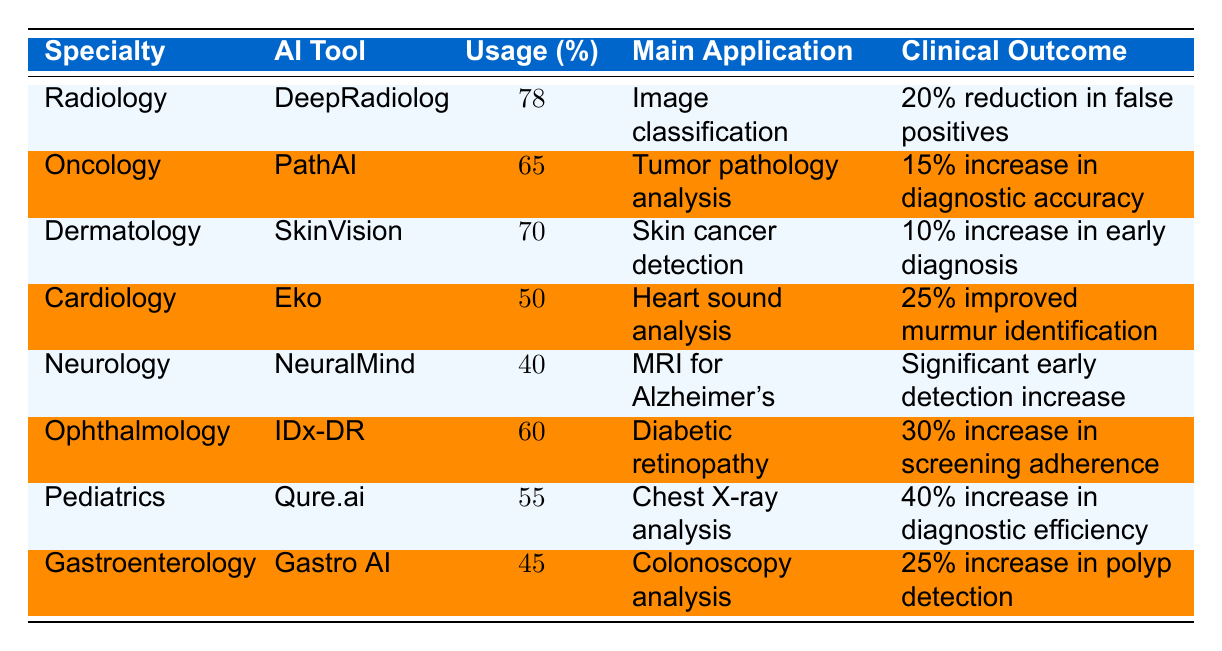What is the AI tool used in Radiology? The table lists the medical specialty of Radiology and the corresponding AI tool, which is DeepRadiology.
Answer: DeepRadiology What is the usage percentage of AI-assisted tools in Oncology? The table shows that the usage percentage of AI-assisted tools in Oncology is 65%.
Answer: 65% Which medical specialty has the highest AI tool utilization? By comparing the usage percentages in the table, Radiology has the highest at 78%.
Answer: Radiology How many medical specialties have an AI tool utilization above 60%? The table shows that Radiology (78%), Oncology (65%), and Dermatology (70%) have usage above 60%, totaling three specialties.
Answer: 3 What is the main application of the tool used in Ophthalmology? The table indicates that the main application of IDx-DR, the AI tool used in Ophthalmology, is diabetic retinopathy screening.
Answer: Diabetic retinopathy screening Is it true that Cardiology has a lower AI tool utilization than Neurology? By looking at the table, Cardiology has a utilization of 50% while Neurology has 40%, which means Cardiology has a higher utilization.
Answer: False What is the total percentage usage of AI tools for Dermatology and Gastroenterology combined? The usage percentage of Dermatology is 70%, and for Gastroenterology, it is 45%. Adding them together yields 70 + 45 = 115%.
Answer: 115% Which specialty shows a 40% increase in diagnostic efficiency? Referring to the table, Pediatrics with Qure.ai shows a 40% increase in diagnostic efficiency.
Answer: Pediatrics How much improvement in screening adherence does the tool in Ophthalmology provide compared to the tool in Cardiology? The tool in Ophthalmology provides a 30% increase in screening adherence, while Cardiology offers a 25% improvement in murmur identification. The difference is 30 - 25 = 5%.
Answer: 5% What is the main clinical outcome improvement for DeepRadiology in Radiology? The table specifies that for DeepRadiology, the main clinical outcome improvement is a 20% reduction in false positives.
Answer: 20% reduction in false positives Which AI tool is used for skin cancer detection? The table reveals that the AI tool used for skin cancer detection in Dermatology is SkinVision.
Answer: SkinVision What is the lowest usage percentage among the listed specialties? By checking the usage percentages, Neurology at 40% has the lowest usage percentage of AI-assisted tools.
Answer: 40% Which specialty has the greatest improvement reported in clinical outcomes? The table indicates that Pediatrics with the tool Qure.ai reports a 40% increase in diagnostic efficiency, which is the greatest improvement listed.
Answer: Pediatrics 